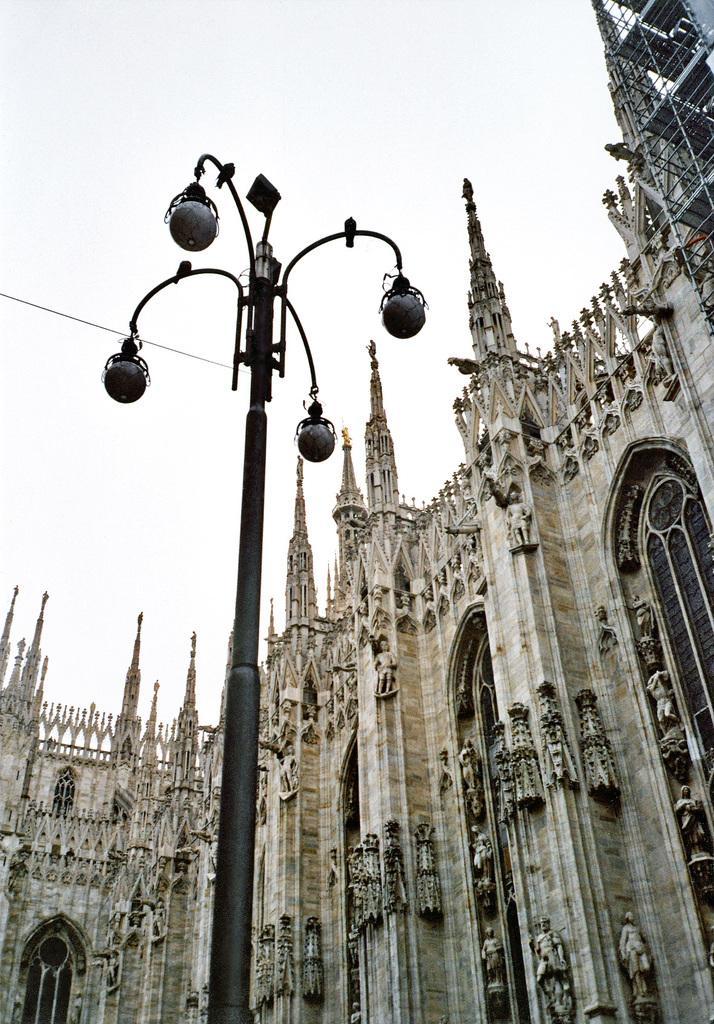Can you describe this image briefly? In this image I can see the lights to the pole. In the background I can see the building and the sky. 